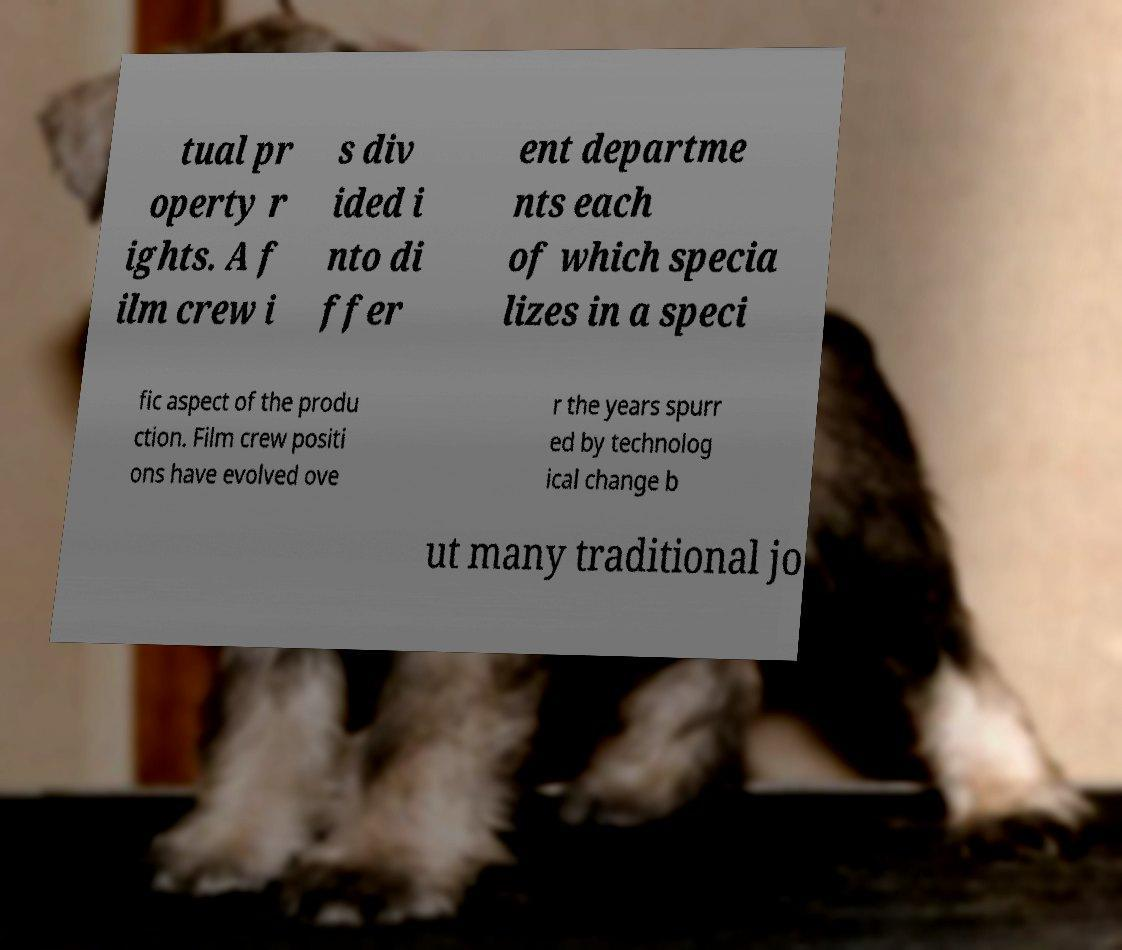Can you accurately transcribe the text from the provided image for me? tual pr operty r ights. A f ilm crew i s div ided i nto di ffer ent departme nts each of which specia lizes in a speci fic aspect of the produ ction. Film crew positi ons have evolved ove r the years spurr ed by technolog ical change b ut many traditional jo 